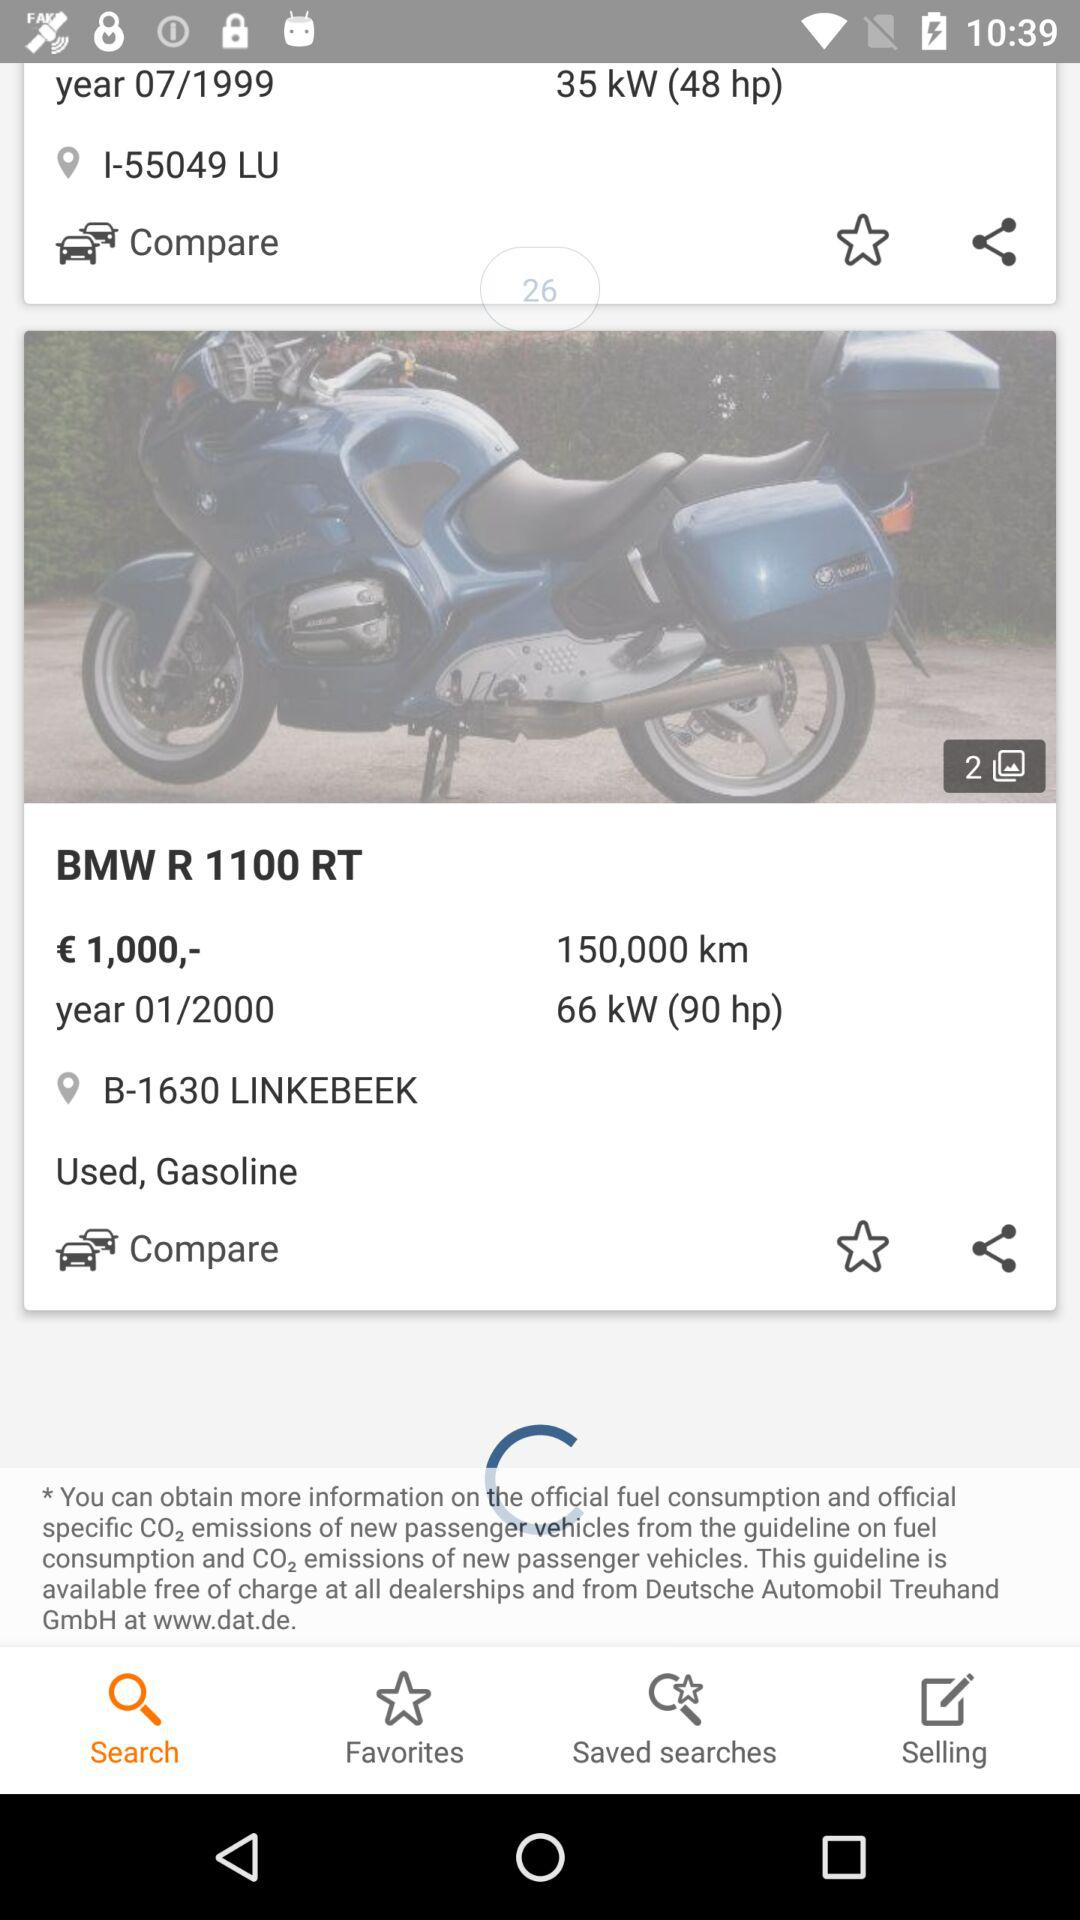Which tab is selected? The selected tab is "Search". 